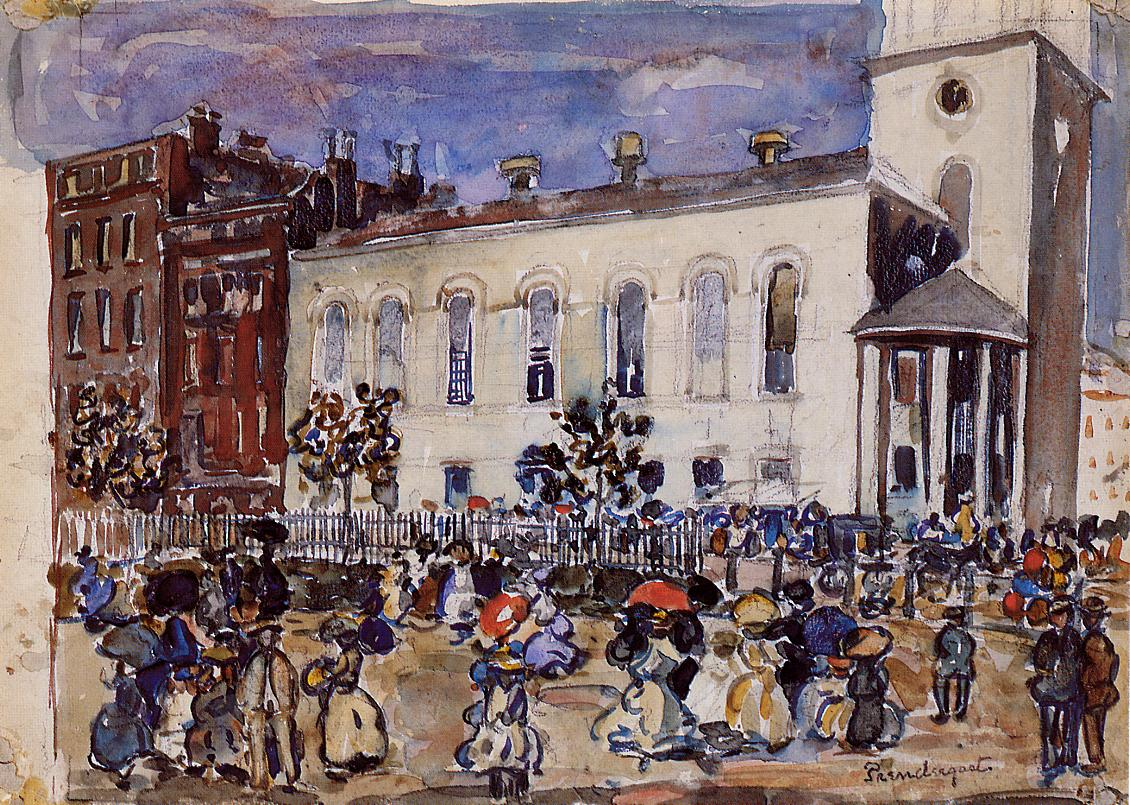What could be some possible historical events influencing this depiction? Several historical events could have influenced this depiction. The early 20th century was a time of significant social and industrial change. The dress and architecture suggest it may be set shortly after the turn of the century, during a time of increasing urbanization and technological advancement. Women in the scene could be participating more publicly as they gradually gained more social and economic freedoms. The scene may also reflect the cultural boom experienced in many cities worldwide, where market days and public gatherings were vibrant displays of community and local economy. Can you describe a possible scene of the people enjoying a significant celebration, and how it might look in such a setting? Imagine the scene transformed for a grand celebration. Banners and bunting in bright colors would be draped across the buildings, and the air would be filled with the lively sounds of a local band playing jubilant tunes. Children would run around with handmade toys, and the aroma of freshly baked goods and roasting meats would waft through the air. The white building, with its towering presence, might serve as the backdrop for speeches or performances. People would be dressed in their finest attire, mingling and sharing stories. Vendors might set up additional stalls, offering festive foods and crafts. As evening approached, lanterns and string lights would illuminate the square, casting a magical glow over the celebratory crowd, capturing the essence of communal joy and togetherness. 